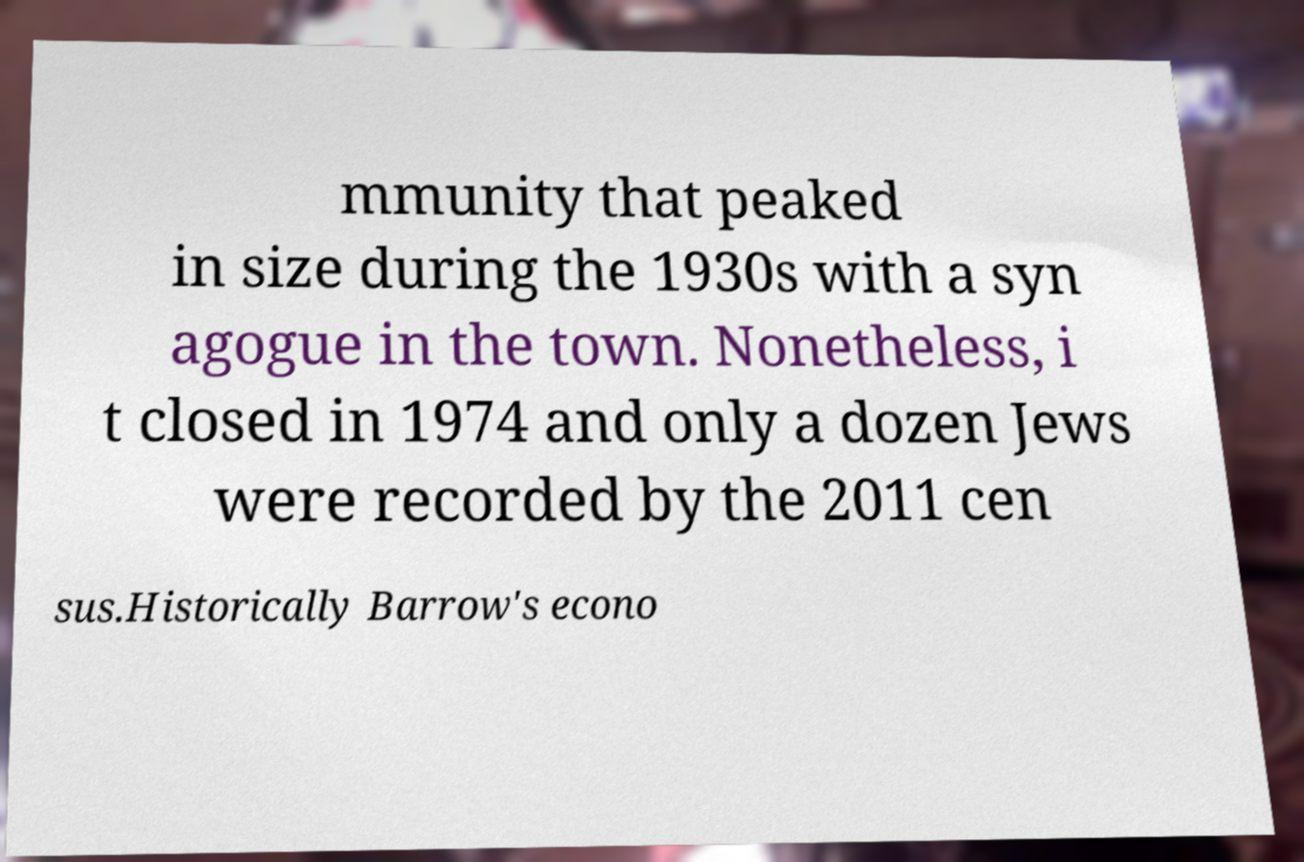Could you extract and type out the text from this image? mmunity that peaked in size during the 1930s with a syn agogue in the town. Nonetheless, i t closed in 1974 and only a dozen Jews were recorded by the 2011 cen sus.Historically Barrow's econo 